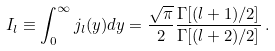Convert formula to latex. <formula><loc_0><loc_0><loc_500><loc_500>I _ { l } \equiv \int _ { 0 } ^ { \infty } j _ { l } ( y ) d y = \frac { \sqrt { \pi } } { 2 } \frac { \Gamma [ ( l + 1 ) / 2 ] } { \Gamma [ ( l + 2 ) / 2 ] } \, .</formula> 